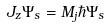Convert formula to latex. <formula><loc_0><loc_0><loc_500><loc_500>J _ { z } \Psi _ { s } = M _ { j } \hbar { \Psi } _ { s }</formula> 